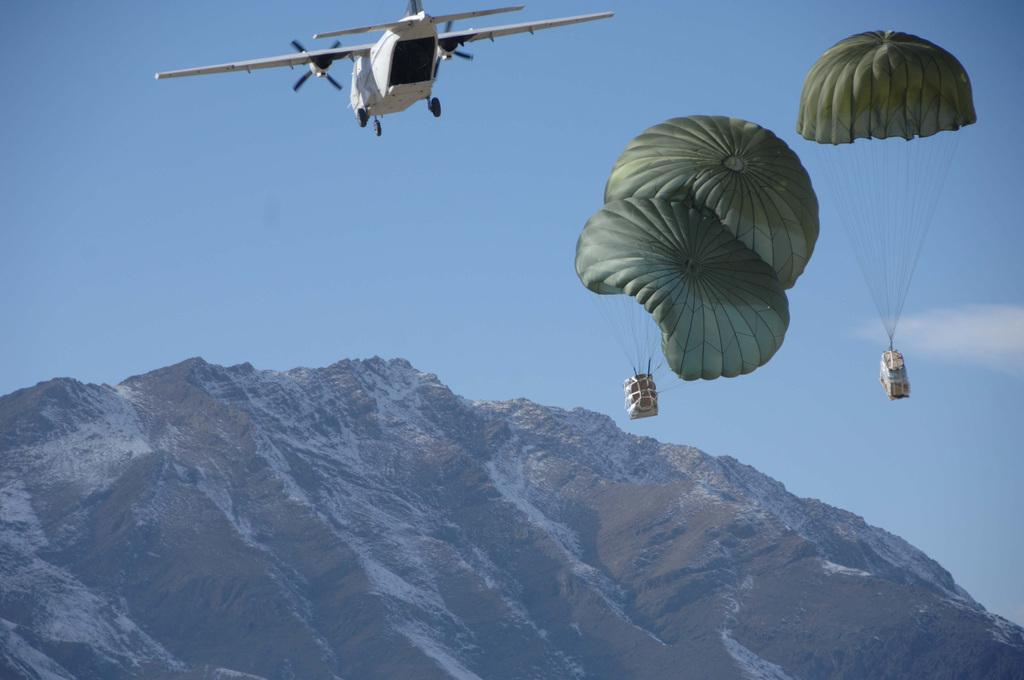What type of natural formation can be seen in the image? There are mountains in the image. What is the condition of the mountains? The mountains have snow on them. What can be seen in the sky in the image? There are two parachutes flying in the sky, and an aircraft is beside them. How many watches can be seen on the mountains in the image? There are no watches present in the image; it features mountains with snow and objects in the sky. Are there any brothers visible in the image? There is no mention of brothers in the image; it only includes mountains, snow, and objects in the sky. 